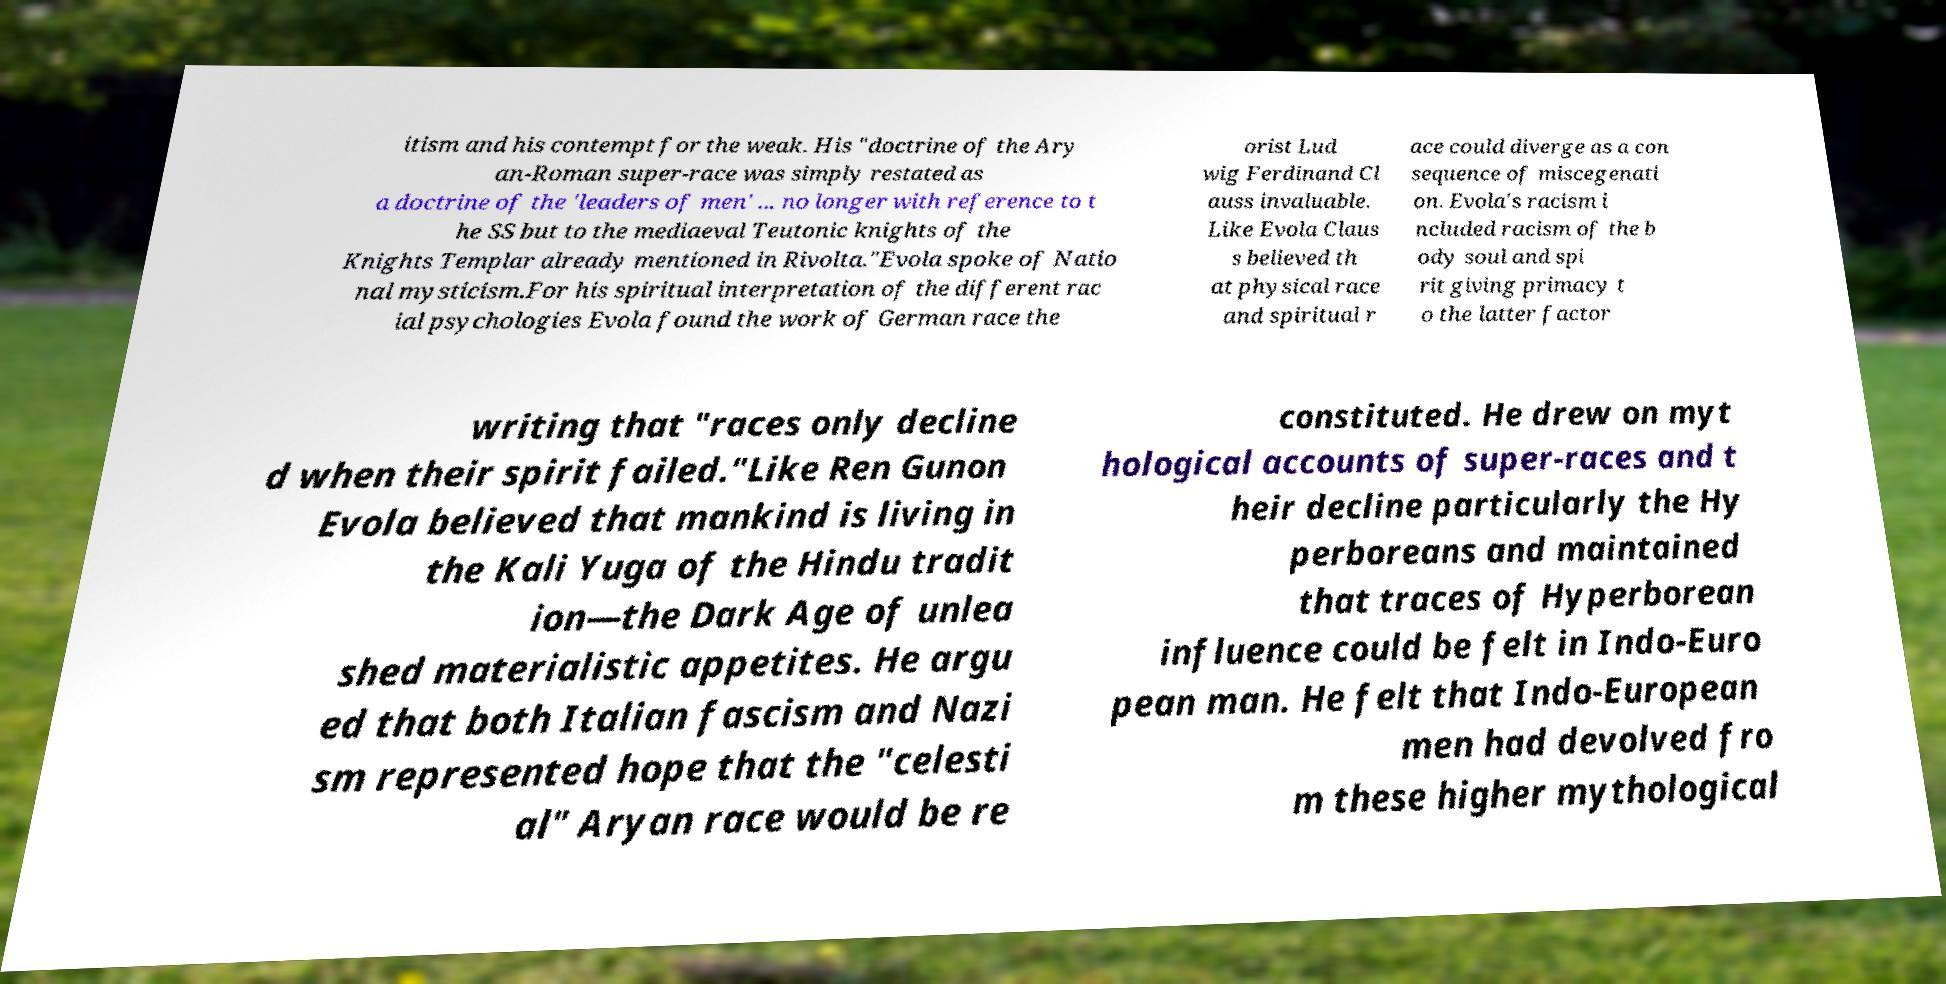Could you assist in decoding the text presented in this image and type it out clearly? itism and his contempt for the weak. His "doctrine of the Ary an-Roman super-race was simply restated as a doctrine of the 'leaders of men' ... no longer with reference to t he SS but to the mediaeval Teutonic knights of the Knights Templar already mentioned in Rivolta."Evola spoke of Natio nal mysticism.For his spiritual interpretation of the different rac ial psychologies Evola found the work of German race the orist Lud wig Ferdinand Cl auss invaluable. Like Evola Claus s believed th at physical race and spiritual r ace could diverge as a con sequence of miscegenati on. Evola's racism i ncluded racism of the b ody soul and spi rit giving primacy t o the latter factor writing that "races only decline d when their spirit failed."Like Ren Gunon Evola believed that mankind is living in the Kali Yuga of the Hindu tradit ion—the Dark Age of unlea shed materialistic appetites. He argu ed that both Italian fascism and Nazi sm represented hope that the "celesti al" Aryan race would be re constituted. He drew on myt hological accounts of super-races and t heir decline particularly the Hy perboreans and maintained that traces of Hyperborean influence could be felt in Indo-Euro pean man. He felt that Indo-European men had devolved fro m these higher mythological 